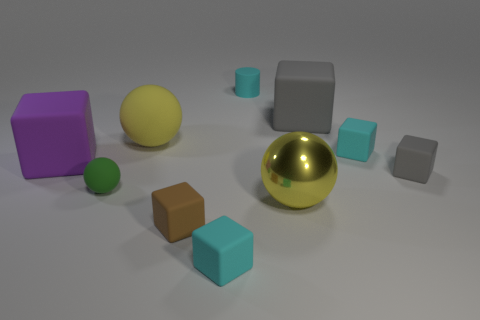Can you describe the lighting in the scene and what kind of atmosphere it creates? The lighting in the scene is soft and diffused, creating a calm and neutral atmosphere. There aren't any harsh shadows or bright highlights, which suggests an evenly lit environment, likely using indirect light sources. This type of lighting minimizes visual distractions and places the focus on the colors and shapes of the objects. 